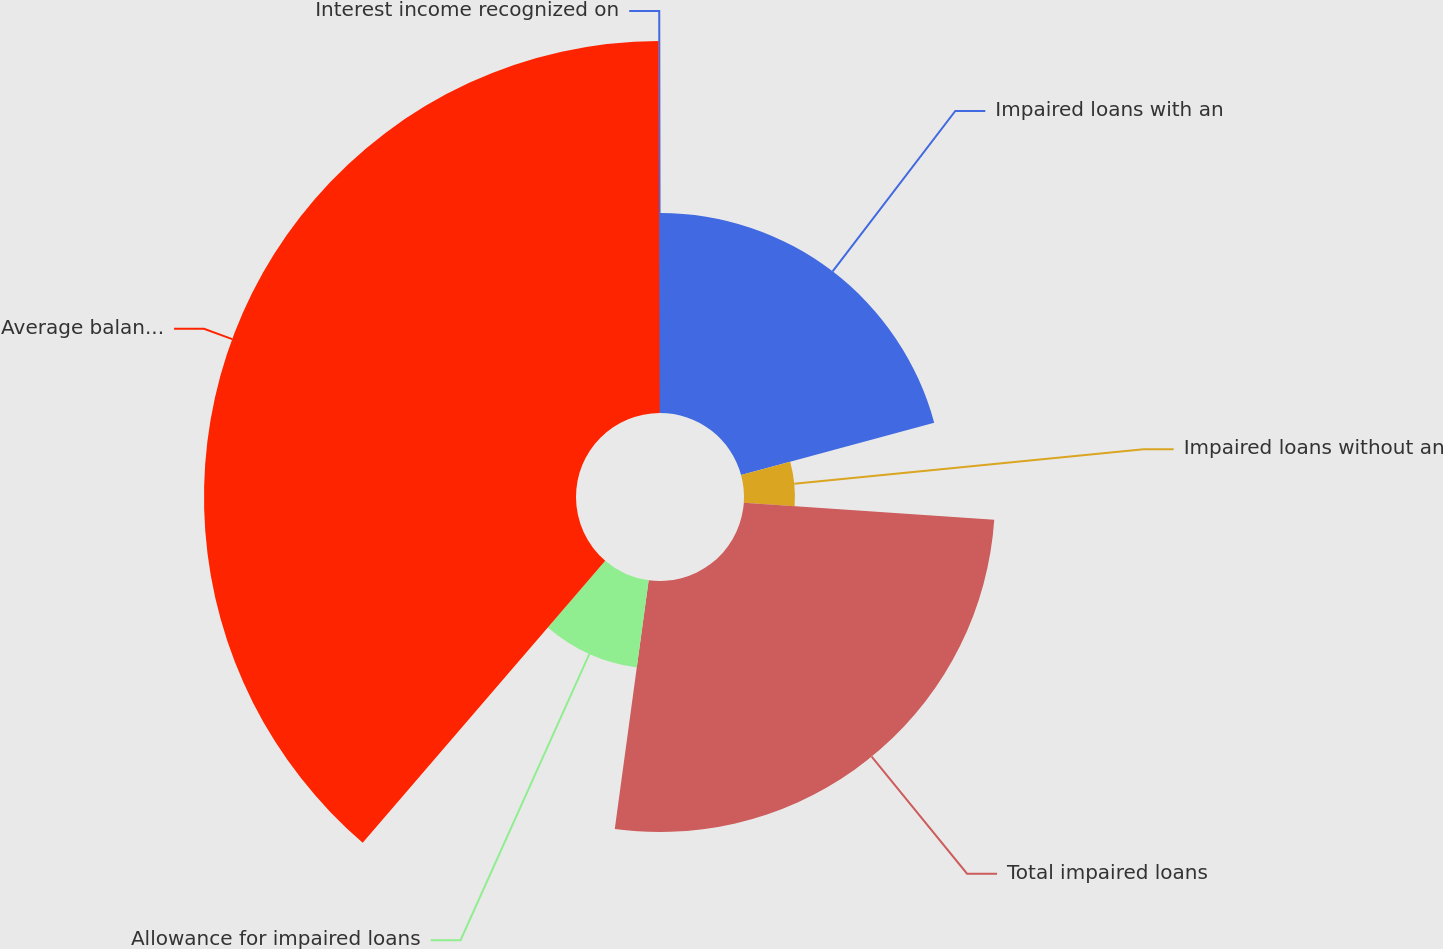Convert chart. <chart><loc_0><loc_0><loc_500><loc_500><pie_chart><fcel>Impaired loans with an<fcel>Impaired loans without an<fcel>Total impaired loans<fcel>Allowance for impaired loans<fcel>Average balance of impaired<fcel>Interest income recognized on<nl><fcel>20.79%<fcel>5.29%<fcel>26.08%<fcel>9.15%<fcel>38.65%<fcel>0.05%<nl></chart> 